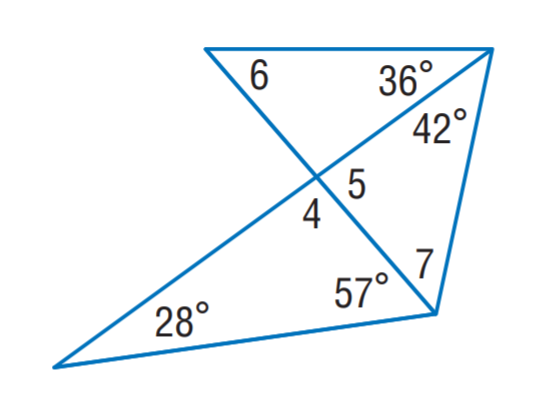Answer the mathemtical geometry problem and directly provide the correct option letter.
Question: Find m \angle 7.
Choices: A: 30 B: 37 C: 49 D: 53 D 